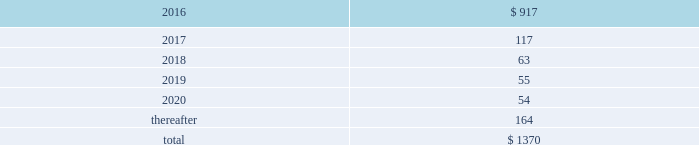Guarantees and warranties in april 2015 , we entered into joint venture arrangements in saudi arabia .
An equity bridge loan has been provided to the joint venture until 2020 to fund equity commitments , and we guaranteed the repayment of our 25% ( 25 % ) share of this loan .
Our venture partner guaranteed repayment of their share .
Our maximum exposure under the guarantee is approximately $ 100 .
As of 30 september 2015 , we recorded a noncurrent liability of $ 67.5 for our obligation to make future equity contributions based on the equity bridge loan .
Air products has also entered into a sale of equipment contract with the joint venture to engineer , procure , and construct the industrial gas facilities that will supply gases to saudi aramco .
We will provide bank guarantees to the joint venture of up to $ 326 to support our performance under the contract .
We are party to an equity support agreement and operations guarantee related to an air separation facility constructed in trinidad for a venture in which we own 50% ( 50 % ) .
At 30 september 2015 , maximum potential payments under joint and several guarantees were $ 30.0 .
Exposures under the guarantee decline over time and will be completely extinguished by 2024 .
During the first quarter of 2014 , we sold the remaining portion of our homecare business and entered into an operations guarantee related to obligations under certain homecare contracts assigned in connection with the transaction .
Our maximum potential payment under the guarantee is a320 million ( approximately $ 30 at 30 september 2015 ) , and our exposure will be extinguished by 2020 .
To date , no equity contributions or payments have been made since the inception of these guarantees .
The fair value of the above guarantees is not material .
We , in the normal course of business operations , have issued product warranties related to equipment sales .
Also , contracts often contain standard terms and conditions which typically include a warranty and indemnification to the buyer that the goods and services purchased do not infringe on third-party intellectual property rights .
The provision for estimated future costs relating to warranties is not material to the consolidated financial statements .
We do not expect that any sum we may have to pay in connection with guarantees and warranties will have a material adverse effect on our consolidated financial condition , liquidity , or results of operations .
Unconditional purchase obligations we are obligated to make future payments under unconditional purchase obligations as summarized below: .
Approximately $ 390 of our long-term unconditional purchase obligations relate to feedstock supply for numerous hyco ( hydrogen , carbon monoxide , and syngas ) facilities .
The price of feedstock supply is principally related to the price of natural gas .
However , long-term take-or-pay sales contracts to hyco customers are generally matched to the term of the feedstock supply obligations and provide recovery of price increases in the feedstock supply .
Due to the matching of most long-term feedstock supply obligations to customer sales contracts , we do not believe these purchase obligations would have a material effect on our financial condition or results of operations .
The unconditional purchase obligations also include other product supply and purchase commitments and electric power and natural gas supply purchase obligations , which are primarily pass-through contracts with our customers .
Purchase commitments to spend approximately $ 540 for additional plant and equipment are included in the unconditional purchase obligations in 2016. .
What is the impact of 2018's unconditional purchase obligations on the total value? 
Rationale: it is 2018's value of unconditional purchase obligations divided by the total , then turned into a percentage to represent the impact .
Computations: (63 / 1370)
Answer: 0.04599. 